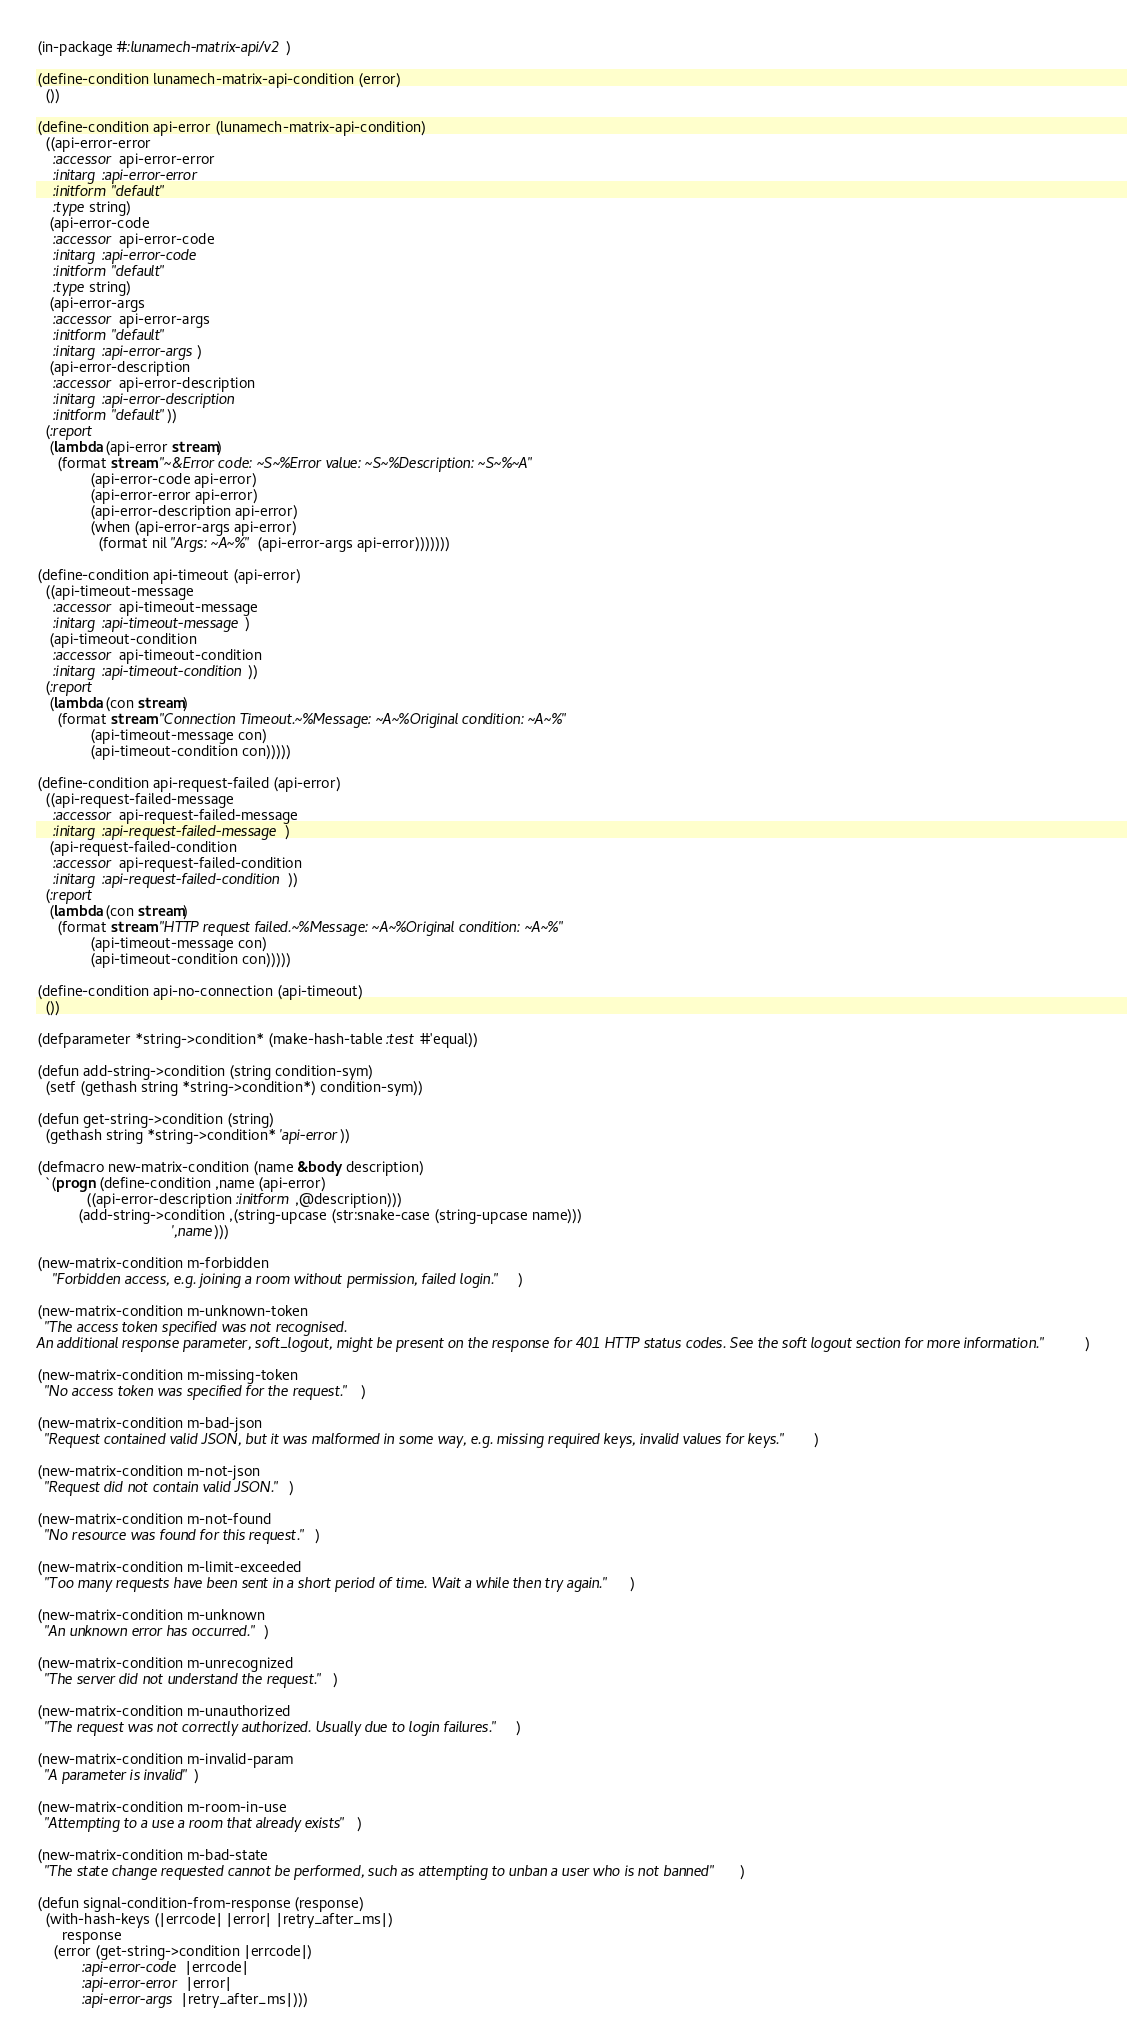<code> <loc_0><loc_0><loc_500><loc_500><_Lisp_>(in-package #:lunamech-matrix-api/v2)

(define-condition lunamech-matrix-api-condition (error)
  ())

(define-condition api-error (lunamech-matrix-api-condition)
  ((api-error-error
    :accessor api-error-error
    :initarg :api-error-error
    :initform "default"
    :type string)
   (api-error-code
    :accessor api-error-code
    :initarg :api-error-code
    :initform "default"
    :type string)
   (api-error-args
    :accessor api-error-args
    :initform "default"
    :initarg :api-error-args)
   (api-error-description
    :accessor api-error-description
    :initarg :api-error-description
    :initform "default"))
  (:report
   (lambda (api-error stream)
     (format stream "~&Error code: ~S~%Error value: ~S~%Description: ~S~%~A"
             (api-error-code api-error)
             (api-error-error api-error)
             (api-error-description api-error)
             (when (api-error-args api-error)
               (format nil "Args: ~A~%" (api-error-args api-error)))))))

(define-condition api-timeout (api-error)
  ((api-timeout-message
    :accessor api-timeout-message
    :initarg :api-timeout-message)
   (api-timeout-condition
    :accessor api-timeout-condition
    :initarg :api-timeout-condition))
  (:report
   (lambda (con stream)
     (format stream "Connection Timeout.~%Message: ~A~%Original condition: ~A~%"
             (api-timeout-message con)
             (api-timeout-condition con)))))

(define-condition api-request-failed (api-error)
  ((api-request-failed-message
    :accessor api-request-failed-message
    :initarg :api-request-failed-message)
   (api-request-failed-condition
    :accessor api-request-failed-condition
    :initarg :api-request-failed-condition))
  (:report
   (lambda (con stream)
     (format stream "HTTP request failed.~%Message: ~A~%Original condition: ~A~%"
             (api-timeout-message con)
             (api-timeout-condition con)))))

(define-condition api-no-connection (api-timeout)
  ())

(defparameter *string->condition* (make-hash-table :test #'equal))

(defun add-string->condition (string condition-sym)
  (setf (gethash string *string->condition*) condition-sym))

(defun get-string->condition (string)
  (gethash string *string->condition* 'api-error))

(defmacro new-matrix-condition (name &body description)
  `(progn (define-condition ,name (api-error)
            ((api-error-description :initform ,@description)))
          (add-string->condition ,(string-upcase (str:snake-case (string-upcase name)))
                                 ',name)))

(new-matrix-condition m-forbidden 
    "Forbidden access, e.g. joining a room without permission, failed login.")

(new-matrix-condition m-unknown-token 
  "The access token specified was not recognised.
An additional response parameter, soft_logout, might be present on the response for 401 HTTP status codes. See the soft logout section for more information.")

(new-matrix-condition m-missing-token 
  "No access token was specified for the request.")

(new-matrix-condition m-bad-json 
  "Request contained valid JSON, but it was malformed in some way, e.g. missing required keys, invalid values for keys.")

(new-matrix-condition m-not-json 
  "Request did not contain valid JSON.")

(new-matrix-condition m-not-found 
  "No resource was found for this request.")

(new-matrix-condition m-limit-exceeded 
  "Too many requests have been sent in a short period of time. Wait a while then try again.")

(new-matrix-condition m-unknown 
  "An unknown error has occurred.")

(new-matrix-condition m-unrecognized 
  "The server did not understand the request.")

(new-matrix-condition m-unauthorized 
  "The request was not correctly authorized. Usually due to login failures.")

(new-matrix-condition m-invalid-param 
  "A parameter is invalid")

(new-matrix-condition m-room-in-use 
  "Attempting to a use a room that already exists")

(new-matrix-condition m-bad-state 
  "The state change requested cannot be performed, such as attempting to unban a user who is not banned")

(defun signal-condition-from-response (response)
  (with-hash-keys (|errcode| |error| |retry_after_ms|)
      response
    (error (get-string->condition |errcode|)
           :api-error-code |errcode|
           :api-error-error |error|
           :api-error-args |retry_after_ms|)))

</code> 